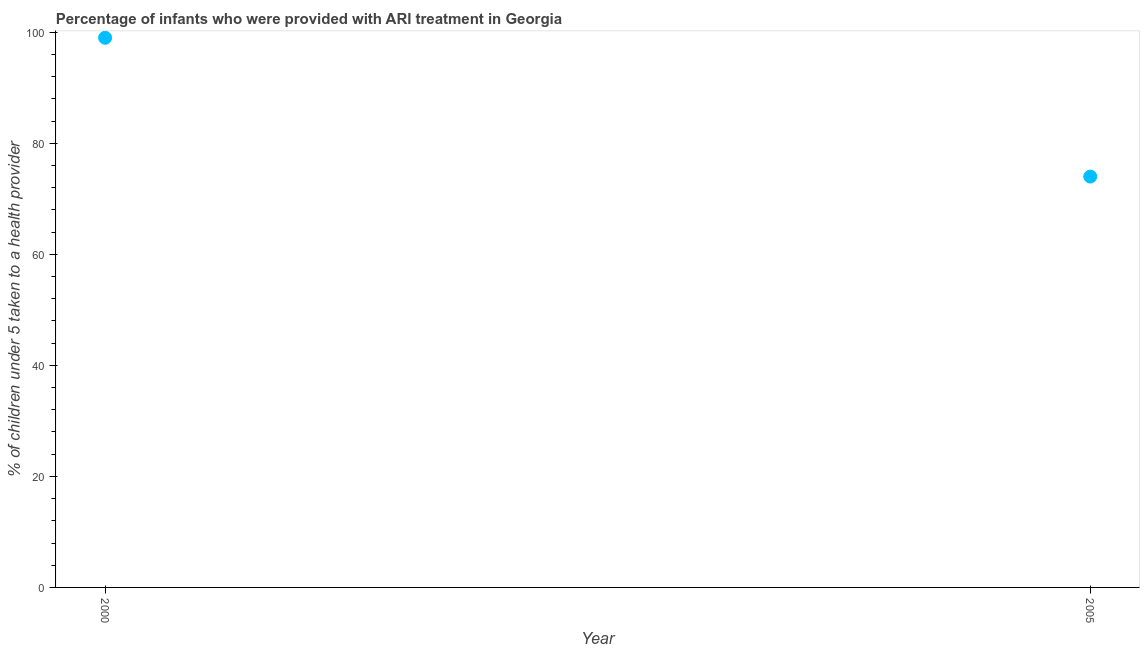What is the percentage of children who were provided with ari treatment in 2005?
Provide a short and direct response. 74. Across all years, what is the maximum percentage of children who were provided with ari treatment?
Make the answer very short. 99. Across all years, what is the minimum percentage of children who were provided with ari treatment?
Provide a short and direct response. 74. In which year was the percentage of children who were provided with ari treatment maximum?
Make the answer very short. 2000. What is the sum of the percentage of children who were provided with ari treatment?
Offer a very short reply. 173. What is the difference between the percentage of children who were provided with ari treatment in 2000 and 2005?
Ensure brevity in your answer.  25. What is the average percentage of children who were provided with ari treatment per year?
Offer a very short reply. 86.5. What is the median percentage of children who were provided with ari treatment?
Give a very brief answer. 86.5. What is the ratio of the percentage of children who were provided with ari treatment in 2000 to that in 2005?
Offer a terse response. 1.34. Is the percentage of children who were provided with ari treatment in 2000 less than that in 2005?
Provide a succinct answer. No. In how many years, is the percentage of children who were provided with ari treatment greater than the average percentage of children who were provided with ari treatment taken over all years?
Offer a very short reply. 1. Does the percentage of children who were provided with ari treatment monotonically increase over the years?
Make the answer very short. No. What is the difference between two consecutive major ticks on the Y-axis?
Keep it short and to the point. 20. Are the values on the major ticks of Y-axis written in scientific E-notation?
Offer a terse response. No. Does the graph contain any zero values?
Your response must be concise. No. What is the title of the graph?
Offer a very short reply. Percentage of infants who were provided with ARI treatment in Georgia. What is the label or title of the X-axis?
Provide a short and direct response. Year. What is the label or title of the Y-axis?
Ensure brevity in your answer.  % of children under 5 taken to a health provider. What is the % of children under 5 taken to a health provider in 2000?
Your answer should be compact. 99. What is the difference between the % of children under 5 taken to a health provider in 2000 and 2005?
Keep it short and to the point. 25. What is the ratio of the % of children under 5 taken to a health provider in 2000 to that in 2005?
Your answer should be very brief. 1.34. 